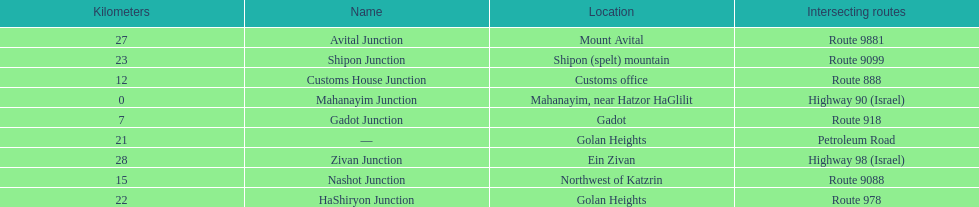What is the number of routes that intersect highway 91? 9. 